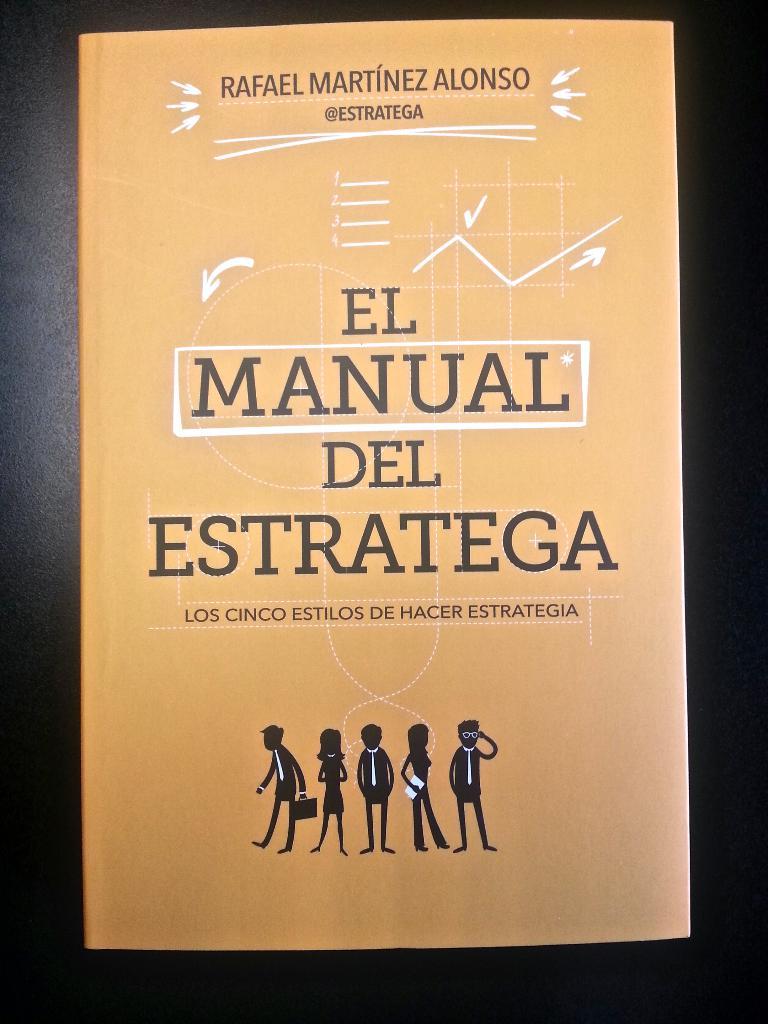What language is the text written in?
Ensure brevity in your answer.  Spanish. 